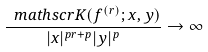Convert formula to latex. <formula><loc_0><loc_0><loc_500><loc_500>\frac { \ m a t h s c r { K } ( f ^ { ( r ) } ; x , y ) } { | x | ^ { p r + p } | y | ^ { p } } \to \infty</formula> 